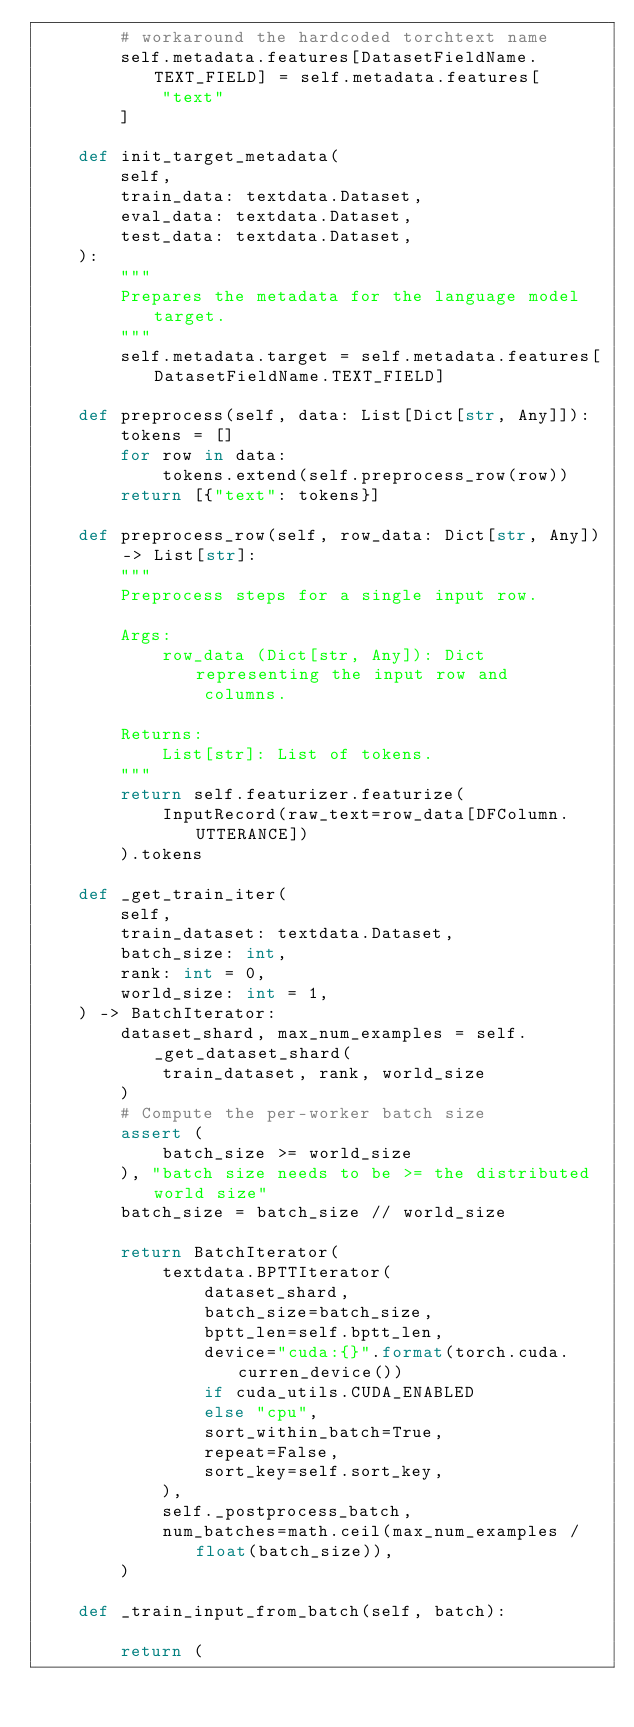<code> <loc_0><loc_0><loc_500><loc_500><_Python_>        # workaround the hardcoded torchtext name
        self.metadata.features[DatasetFieldName.TEXT_FIELD] = self.metadata.features[
            "text"
        ]

    def init_target_metadata(
        self,
        train_data: textdata.Dataset,
        eval_data: textdata.Dataset,
        test_data: textdata.Dataset,
    ):
        """
        Prepares the metadata for the language model target.
        """
        self.metadata.target = self.metadata.features[DatasetFieldName.TEXT_FIELD]

    def preprocess(self, data: List[Dict[str, Any]]):
        tokens = []
        for row in data:
            tokens.extend(self.preprocess_row(row))
        return [{"text": tokens}]

    def preprocess_row(self, row_data: Dict[str, Any]) -> List[str]:
        """
        Preprocess steps for a single input row.

        Args:
            row_data (Dict[str, Any]): Dict representing the input row and
                columns.

        Returns:
            List[str]: List of tokens.
        """
        return self.featurizer.featurize(
            InputRecord(raw_text=row_data[DFColumn.UTTERANCE])
        ).tokens

    def _get_train_iter(
        self,
        train_dataset: textdata.Dataset,
        batch_size: int,
        rank: int = 0,
        world_size: int = 1,
    ) -> BatchIterator:
        dataset_shard, max_num_examples = self._get_dataset_shard(
            train_dataset, rank, world_size
        )
        # Compute the per-worker batch size
        assert (
            batch_size >= world_size
        ), "batch size needs to be >= the distributed world size"
        batch_size = batch_size // world_size

        return BatchIterator(
            textdata.BPTTIterator(
                dataset_shard,
                batch_size=batch_size,
                bptt_len=self.bptt_len,
                device="cuda:{}".format(torch.cuda.curren_device())
                if cuda_utils.CUDA_ENABLED
                else "cpu",
                sort_within_batch=True,
                repeat=False,
                sort_key=self.sort_key,
            ),
            self._postprocess_batch,
            num_batches=math.ceil(max_num_examples / float(batch_size)),
        )

    def _train_input_from_batch(self, batch):

        return (</code> 